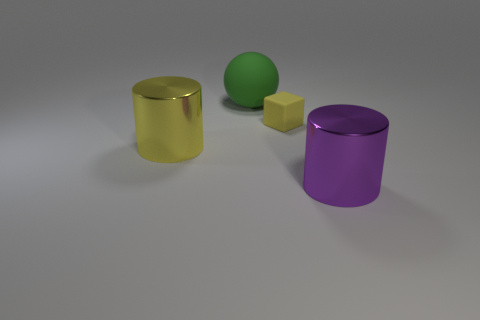How many large things are left of the purple cylinder and in front of the large green thing?
Ensure brevity in your answer.  1. Is there anything else that is the same shape as the large purple thing?
Keep it short and to the point. Yes. There is a small matte object; is its color the same as the thing to the right of the tiny thing?
Provide a succinct answer. No. There is a yellow object to the right of the big green sphere; what shape is it?
Keep it short and to the point. Cube. What is the tiny yellow block made of?
Offer a terse response. Rubber. How many tiny objects are either red metallic cubes or green things?
Offer a very short reply. 0. There is a purple cylinder; what number of small yellow blocks are behind it?
Keep it short and to the point. 1. Are there any shiny things that have the same color as the cube?
Offer a terse response. Yes. There is a green rubber thing that is the same size as the purple cylinder; what is its shape?
Your response must be concise. Sphere. What number of purple things are either large shiny things or rubber spheres?
Your answer should be very brief. 1. 